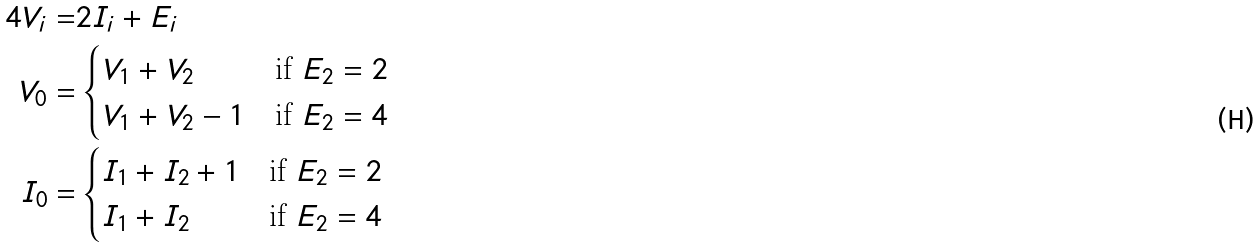Convert formula to latex. <formula><loc_0><loc_0><loc_500><loc_500>4 V _ { i } = & 2 I _ { i } + E _ { i } \\ V _ { 0 } = & \begin{cases} V _ { 1 } + V _ { 2 } & \text {if $E_{2}=2$} \\ V _ { 1 } + V _ { 2 } - 1 & \text {if $E_{2}=4$} \end{cases} \\ I _ { 0 } = & \begin{cases} I _ { 1 } + I _ { 2 } + 1 & \text {if $E_{2}=2$} \\ I _ { 1 } + I _ { 2 } & \text {if $E_{2}=4$} \end{cases}</formula> 